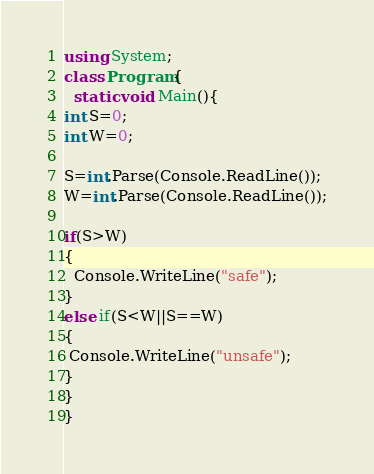Convert code to text. <code><loc_0><loc_0><loc_500><loc_500><_C#_>using System;
class Program{
  static void Main(){
int S=0;
int W=0;
 
S=int.Parse(Console.ReadLine());
W=int.Parse(Console.ReadLine());
 
if(S>W)
{
  Console.WriteLine("safe");
}
else if(S<W||S==W)
{
 Console.WriteLine("unsafe");
}
} 
}</code> 